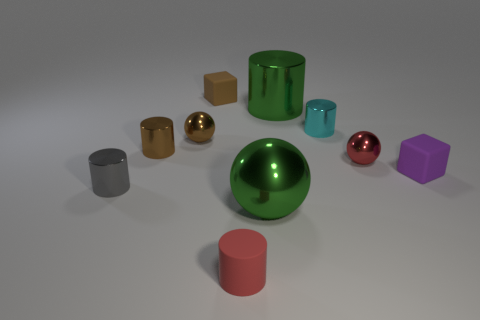Subtract all big green balls. How many balls are left? 2 Subtract all red cylinders. How many cylinders are left? 4 Subtract all blocks. How many objects are left? 8 Subtract all gray balls. Subtract all blue blocks. How many balls are left? 3 Add 7 small brown cylinders. How many small brown cylinders exist? 8 Subtract 0 blue cubes. How many objects are left? 10 Subtract all small metallic things. Subtract all big yellow matte objects. How many objects are left? 5 Add 8 red rubber objects. How many red rubber objects are left? 9 